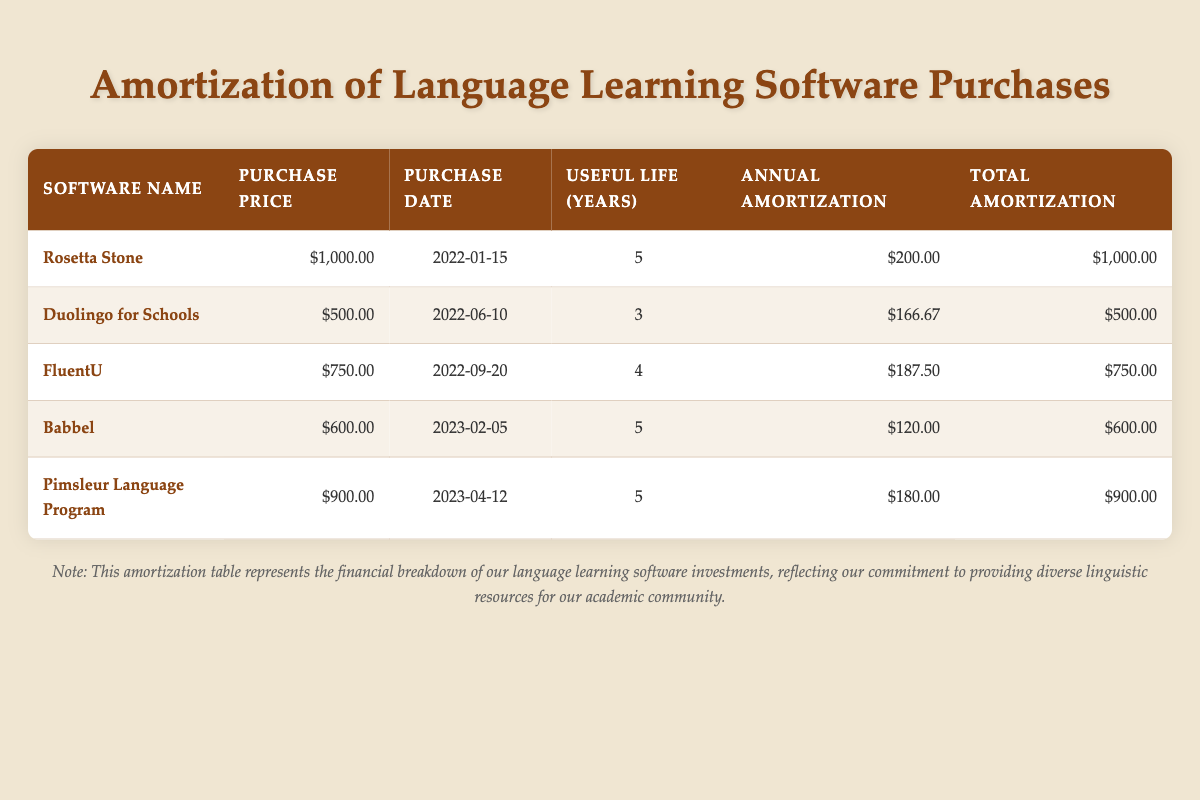What's the purchase price of Rosetta Stone? The purchase price of Rosetta Stone is listed in the table under "Purchase Price." According to the table, it is $1,000.00.
Answer: $1,000.00 How many years of useful life does Duolingo for Schools have? Duolingo for Schools has its useful life indicated in the "Useful Life (Years)" column of the table. The table shows it is 3 years.
Answer: 3 years What is the total amortization for FluentU? The total amortization for FluentU can be found in the "Total Amortization" column of the table. It states that the total amortization for FluentU is $750.00.
Answer: $750.00 Which software has the highest annual amortization amount? To determine which software has the highest annual amortization, I can compare the "Annual Amortization" amounts listed for each software. Rosetta Stone has the highest amount at $200.00.
Answer: Rosetta Stone What is the average purchase price of all the language learning software? To find the average purchase price, sum up all the purchase prices: $1,000.00 + $500.00 + $750.00 + $600.00 + $900.00 = $2,750.00. Then divide by the number of software, which is 5. So, $2,750.00 / 5 = $550.00.
Answer: $550.00 Is Babbel purchased after Duolingo for Schools? To verify this, I look at their purchase dates: Babbel was purchased on 2023-02-05 and Duolingo for Schools on 2022-06-10. Since 2023-02-05 is after 2022-06-10, the statement is true.
Answer: Yes What is the total annual amortization for all software combined? To find the total annual amortization, I add all the annual amortization values: $200.00 + $166.67 + $187.50 + $120.00 + $180.00 = $954.17.
Answer: $954.17 Is the purchase price of Pimsleur Language Program greater than Babbel? The purchase prices are $900.00 for Pimsleur Language Program and $600.00 for Babbel. Since $900.00 is greater than $600.00, the statement is true.
Answer: Yes What is the difference in useful life between FluentU and Babbel? The useful life for FluentU is 4 years, while for Babbel it is 5 years. To find the difference, I subtract 4 from 5, which gives 1 year.
Answer: 1 year If we only consider the software with a useful life of 5 years, what is the average annual amortization? The software with a useful life of 5 years are Rosetta Stone, Babbel, and Pimsleur Language Program with annual amortization amounts of $200.00, $120.00, and $180.00 respectively. Summing these gives $200.00 + $120.00 + $180.00 = $500.00. There are 3 software, so $500.00 / 3 = $166.67.
Answer: $166.67 